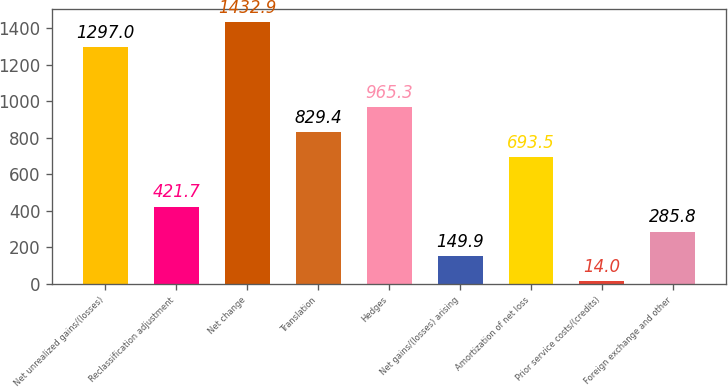Convert chart. <chart><loc_0><loc_0><loc_500><loc_500><bar_chart><fcel>Net unrealized gains/(losses)<fcel>Reclassification adjustment<fcel>Net change<fcel>Translation<fcel>Hedges<fcel>Net gains/(losses) arising<fcel>Amortization of net loss<fcel>Prior service costs/(credits)<fcel>Foreign exchange and other<nl><fcel>1297<fcel>421.7<fcel>1432.9<fcel>829.4<fcel>965.3<fcel>149.9<fcel>693.5<fcel>14<fcel>285.8<nl></chart> 